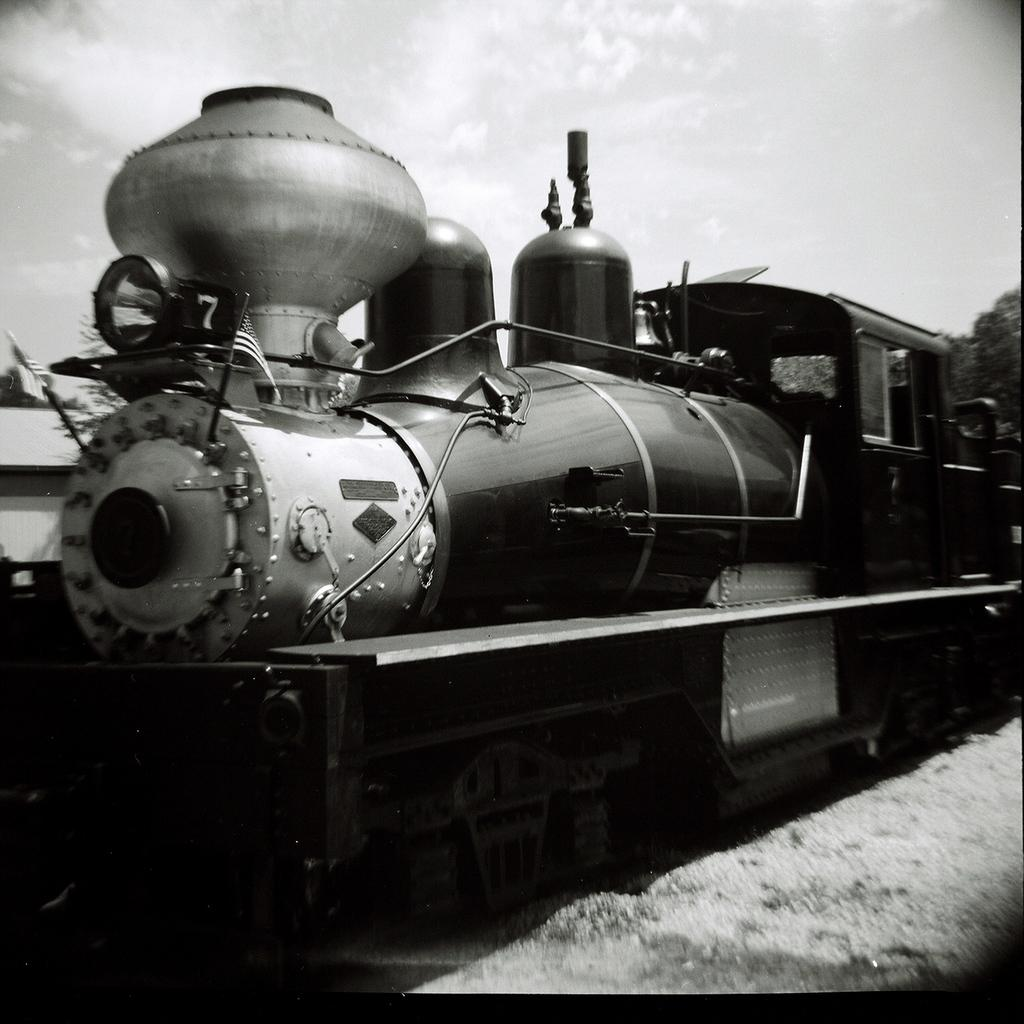What is the color scheme of the image? The image is black and white. What is the main subject of the image? There is a train in the image. What can be seen at the bottom of the image? The ground is visible at the bottom of the image. What is visible at the top of the image? The sky is visible at the top of the image. What type of verse can be seen written on the train in the image? There is no verse visible on the train in the image, as it is a black and white image with no text present. How many zebras are standing near the train in the image? There are no zebras present in the image; it features a train and the surrounding environment. 